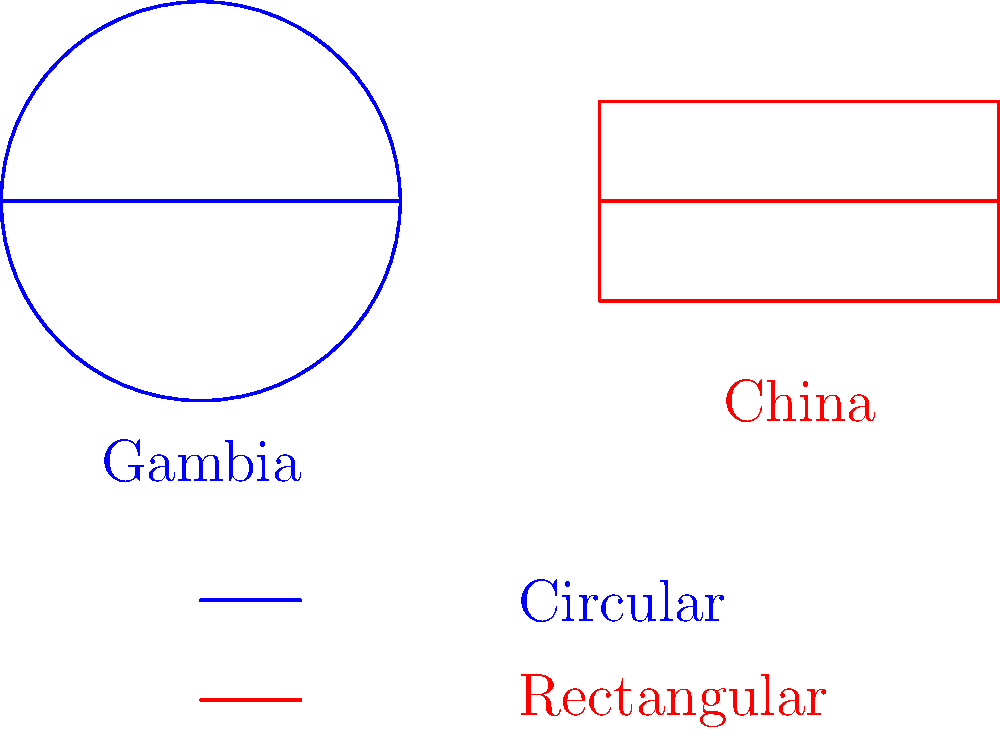Based on the diagram comparing football stadium layouts in Gambia and China, what is the primary difference in shape between the two countries' typical stadium designs? To answer this question, let's analyze the diagram step by step:

1. Look at the blue diagram labeled "Gambia":
   - The shape is a perfect circle
   - There's a straight line across the diameter

2. Examine the red diagram labeled "China":
   - The shape is a rectangle
   - There's a straight line across the middle

3. Compare the two shapes:
   - Gambia's stadium is circular
   - China's stadium is rectangular

4. Identify the primary difference:
   - The main distinction is in the overall shape of the stadiums
   - Gambia uses a circular design
   - China uses a rectangular design

This difference in shape is the most prominent feature distinguishing the two stadium layouts in the diagram.
Answer: Circular (Gambia) vs. Rectangular (China) 